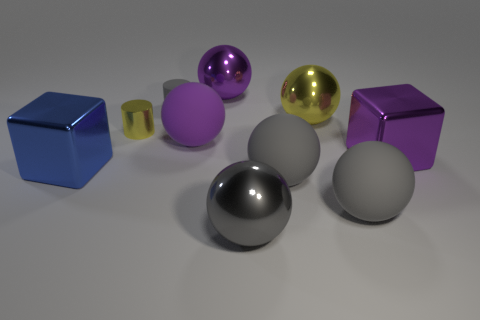Subtract all gray balls. How many were subtracted if there are2gray balls left? 1 Subtract all brown cylinders. How many gray balls are left? 3 Subtract all purple balls. How many balls are left? 4 Subtract 4 balls. How many balls are left? 2 Subtract all gray balls. How many balls are left? 3 Subtract all cylinders. How many objects are left? 8 Subtract all brown spheres. Subtract all red cylinders. How many spheres are left? 6 Add 1 blue shiny things. How many blue shiny things are left? 2 Add 1 rubber cylinders. How many rubber cylinders exist? 2 Subtract 0 gray blocks. How many objects are left? 10 